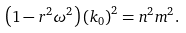<formula> <loc_0><loc_0><loc_500><loc_500>\left ( 1 - r ^ { 2 } \omega ^ { 2 } \right ) \left ( k _ { 0 } \right ) ^ { 2 } = n ^ { 2 } m ^ { 2 } .</formula> 